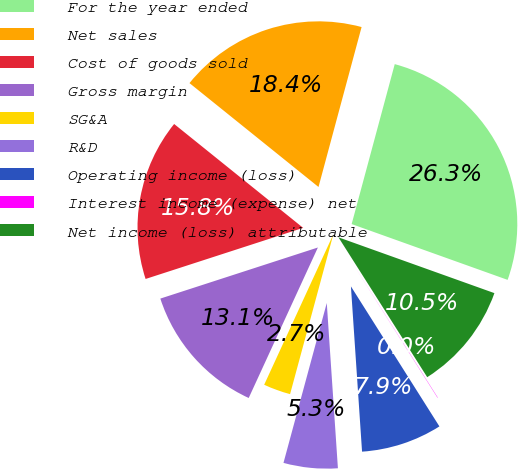<chart> <loc_0><loc_0><loc_500><loc_500><pie_chart><fcel>For the year ended<fcel>Net sales<fcel>Cost of goods sold<fcel>Gross margin<fcel>SG&A<fcel>R&D<fcel>Operating income (loss)<fcel>Interest income (expense) net<fcel>Net income (loss) attributable<nl><fcel>26.28%<fcel>18.4%<fcel>15.78%<fcel>13.15%<fcel>2.65%<fcel>5.28%<fcel>7.9%<fcel>0.03%<fcel>10.53%<nl></chart> 